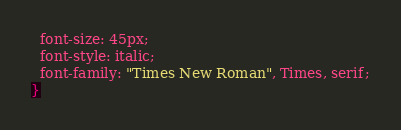<code> <loc_0><loc_0><loc_500><loc_500><_CSS_>  font-size: 45px;
  font-style: italic;
  font-family: "Times New Roman", Times, serif;
}</code> 